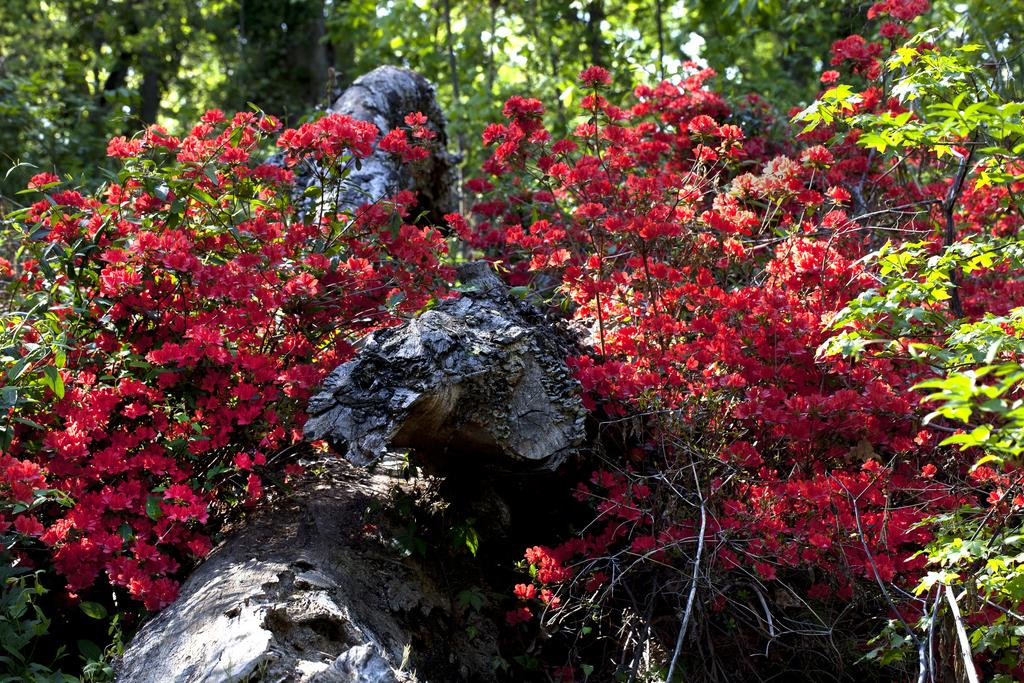What type of plants can be seen in the image? There are plants with a flower in the image. What can be found between the plants? There are rocks between the plants. What is visible in the background of the image? The background of the image is covered with plants. What type of grape is growing on the seashore in the image? There is no grape or seashore present in the image; it features plants with a flower and rocks between them. 